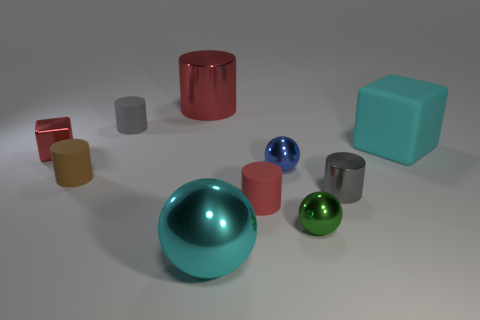Is there a gray cylinder made of the same material as the small brown cylinder?
Give a very brief answer. Yes. There is a shiny cylinder that is the same color as the tiny shiny cube; what size is it?
Your answer should be compact. Large. Are there fewer small balls than large cyan metallic balls?
Offer a terse response. No. There is a small rubber cylinder that is on the right side of the tiny gray rubber thing; is its color the same as the big cylinder?
Give a very brief answer. Yes. What material is the tiny gray cylinder to the left of the gray cylinder on the right side of the red thing in front of the tiny red metal cube?
Your answer should be compact. Rubber. Are there any balls that have the same color as the matte block?
Provide a succinct answer. Yes. Is the number of small red things on the left side of the red metallic cylinder less than the number of tiny balls?
Give a very brief answer. Yes. There is a cyan object that is right of the cyan metallic ball; is its size the same as the tiny gray metal thing?
Offer a very short reply. No. How many objects are behind the cyan metallic sphere and right of the big red metal thing?
Provide a short and direct response. 5. What size is the cylinder to the right of the tiny matte cylinder that is to the right of the large metal ball?
Offer a terse response. Small. 